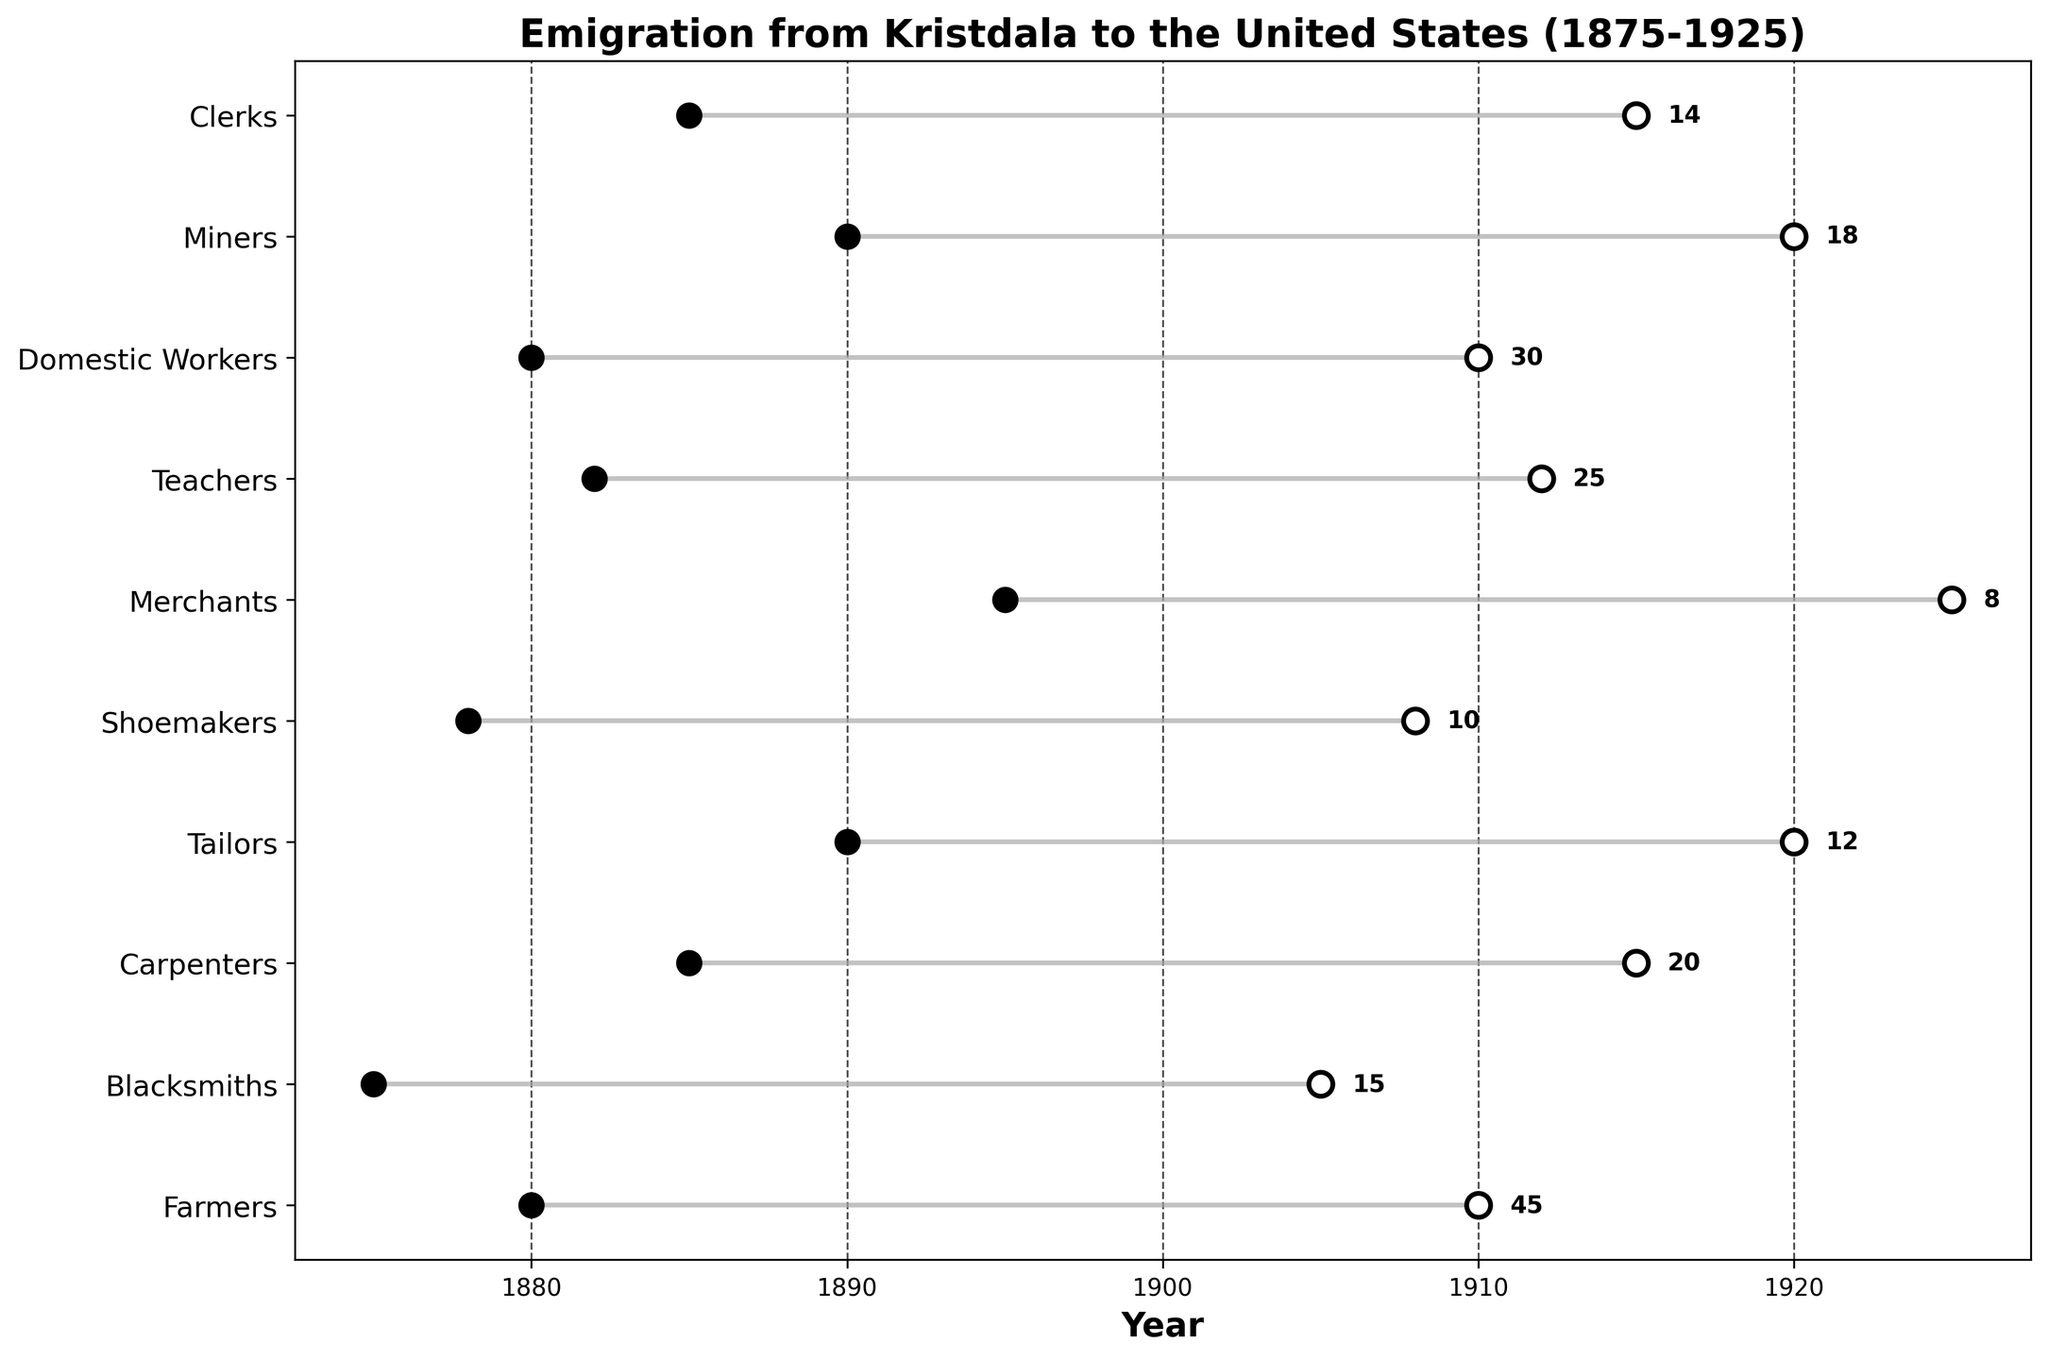what is the time range of emigration for Carpenters? The time range for Carpenters can be seen directly from the plot. They emigrated between the years 1885 and 1915, as indicated by the horizontal line and the start and end points.
Answer: 1885 to 1915 how many Domestic Workers emigrated? The number of Domestic Workers who emigrated is displayed next to their horizontal line. It reads "30".
Answer: 30 which profession shows the earliest emigration period? By comparing the start years of each profession, the earliest emigration period is seen for Blacksmiths, who started in 1875.
Answer: Blacksmiths which profession had the most prolonged emigration period? To determine the longest emigration period, we can calculate the span for each profession. Farmers emigrated from 1880 to 1910, which spans 30 years. Calculating for others, the longest span is 30 years, tied between Farmers, Domestic Workers, and Tailors, but tailored to the data, only Farmers and Domestic Workers span for 30 years.
Answer: Farmers and Domestic Workers how many professions started emigrating in the 1880s? Checking each start year within the 1880s range (1880-1889), we find that Farmers, Carpenters, Domestic Workers, and Teachers started emigrating in the 1880s. Thus, four professions started in this decade.
Answer: 4 compare the total number of Clerks and Miners who emigrated. Which is higher? The total number of Clerks is 14, while the number of Miners is 18. Therefore, more Miners emigrated compared to Clerks.
Answer: Miners what is the timeframe when Teachers emigrated? The time range for Teachers can be read from the plot where their line starts at 1882 and ends at 1912.
Answer: 1882 to 1912 which profession has an equal number of emigrants to Shoemakers? Looking at the Numbers column, Shoemakers have 10 emigrants. Comparing this with other professions, none have exactly 10 emigrants.
Answer: None 